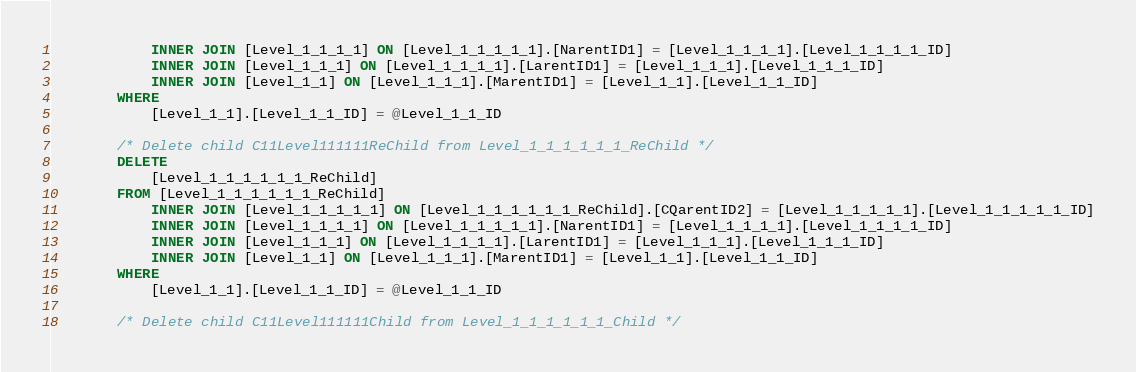Convert code to text. <code><loc_0><loc_0><loc_500><loc_500><_SQL_>            INNER JOIN [Level_1_1_1_1] ON [Level_1_1_1_1_1].[NarentID1] = [Level_1_1_1_1].[Level_1_1_1_1_ID]
            INNER JOIN [Level_1_1_1] ON [Level_1_1_1_1].[LarentID1] = [Level_1_1_1].[Level_1_1_1_ID]
            INNER JOIN [Level_1_1] ON [Level_1_1_1].[MarentID1] = [Level_1_1].[Level_1_1_ID]
        WHERE
            [Level_1_1].[Level_1_1_ID] = @Level_1_1_ID

        /* Delete child C11Level111111ReChild from Level_1_1_1_1_1_1_ReChild */
        DELETE
            [Level_1_1_1_1_1_1_ReChild]
        FROM [Level_1_1_1_1_1_1_ReChild]
            INNER JOIN [Level_1_1_1_1_1] ON [Level_1_1_1_1_1_1_ReChild].[CQarentID2] = [Level_1_1_1_1_1].[Level_1_1_1_1_1_ID]
            INNER JOIN [Level_1_1_1_1] ON [Level_1_1_1_1_1].[NarentID1] = [Level_1_1_1_1].[Level_1_1_1_1_ID]
            INNER JOIN [Level_1_1_1] ON [Level_1_1_1_1].[LarentID1] = [Level_1_1_1].[Level_1_1_1_ID]
            INNER JOIN [Level_1_1] ON [Level_1_1_1].[MarentID1] = [Level_1_1].[Level_1_1_ID]
        WHERE
            [Level_1_1].[Level_1_1_ID] = @Level_1_1_ID

        /* Delete child C11Level111111Child from Level_1_1_1_1_1_1_Child */</code> 